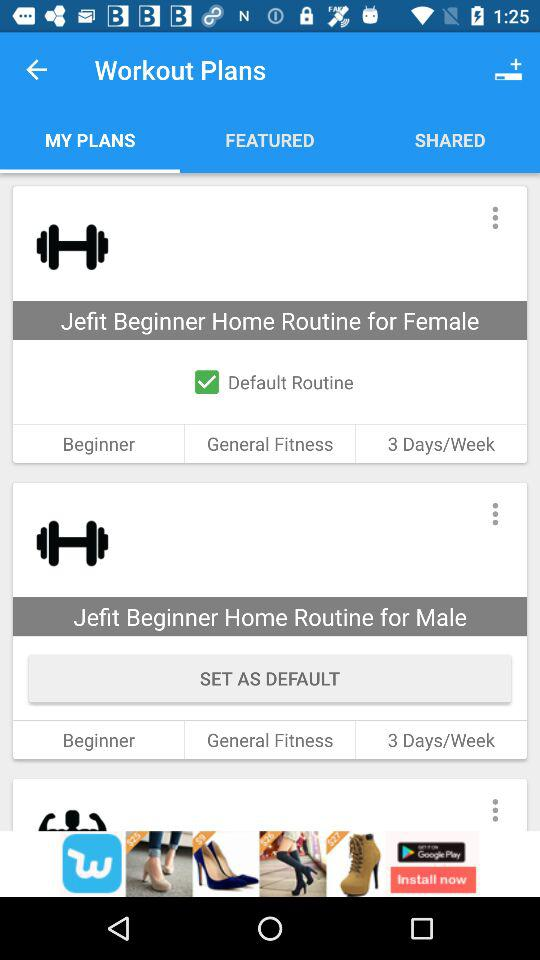What is the status of "Default Routine" for females? The status is "on". 